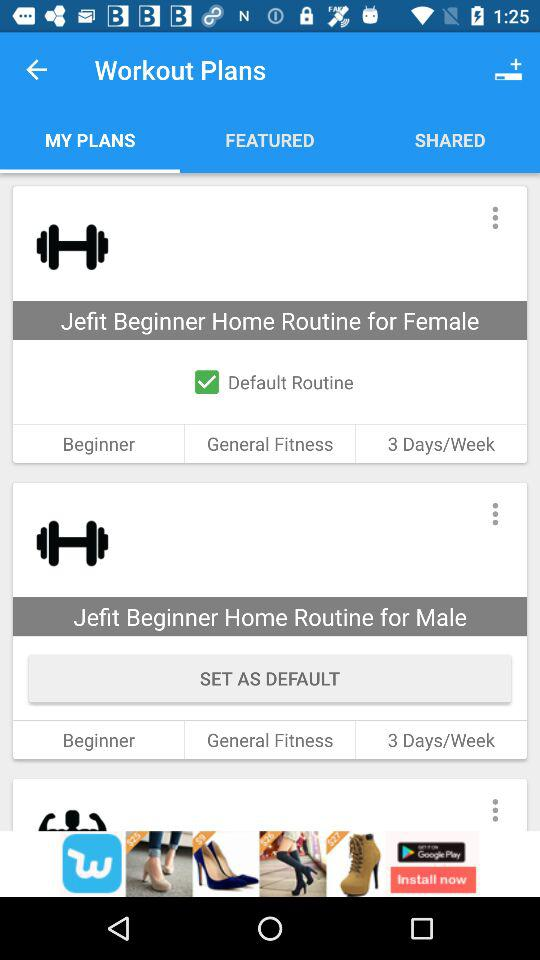What is the status of "Default Routine" for females? The status is "on". 